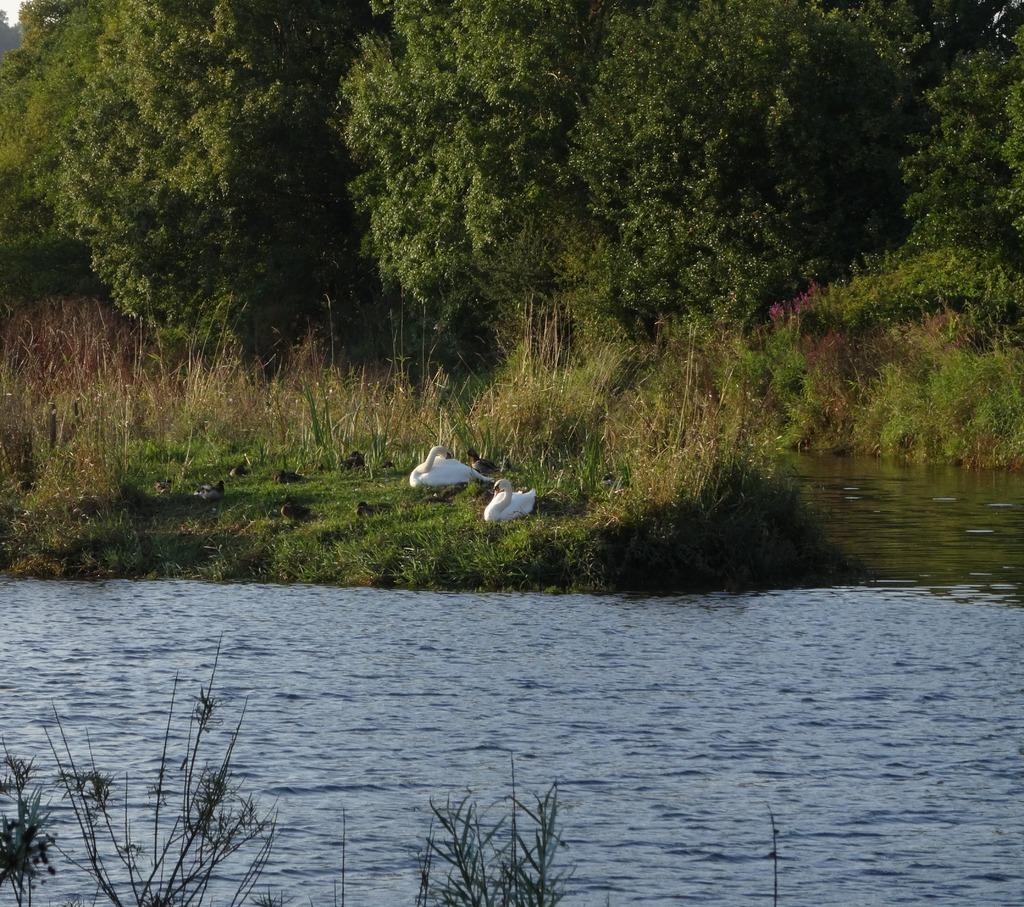What type of animals are in the image? There are swans in the image. What natural element is visible in the image? There is water visible in the image. What type of vegetation can be seen in the image? There are trees and plants in the image. Where can you find the zoo in the image? There is no zoo present in the image. What type of cleaning product is visible in the image? There is no soap present in the image. What type of snack is being served in the image? There is no popcorn present in the image. 